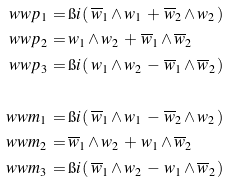Convert formula to latex. <formula><loc_0><loc_0><loc_500><loc_500>\ w w p _ { 1 } \, = \, & \i i \, ( \, \overline { w } _ { 1 } \wedge w _ { 1 } \, + \, \overline { w } _ { 2 } \wedge w _ { 2 } \, ) \\ \ w w p _ { 2 } \, = \, & w _ { 1 } \wedge w _ { 2 } \, + \, \overline { w } _ { 1 } \wedge \overline { w } _ { 2 } \\ \ w w p _ { 3 } \, = \, & \i i \, ( \, w _ { 1 } \wedge w _ { 2 } \, - \, \overline { w } _ { 1 } \wedge \overline { w } _ { 2 } \, ) \\ & \\ \ w w m _ { 1 } \, = \, & \i i \, ( \, \overline { w } _ { 1 } \wedge w _ { 1 } \, - \, \overline { w } _ { 2 } \wedge w _ { 2 } \, ) \\ \ w w m _ { 2 } \, = \, & \overline { w } _ { 1 } \wedge w _ { 2 } \, + \, w _ { 1 } \wedge \overline { w } _ { 2 } \\ \ w w m _ { 3 } \, = \, & \i i \, ( \, \overline { w } _ { 1 } \wedge w _ { 2 } \, - \, w _ { 1 } \wedge \overline { w } _ { 2 } \, )</formula> 